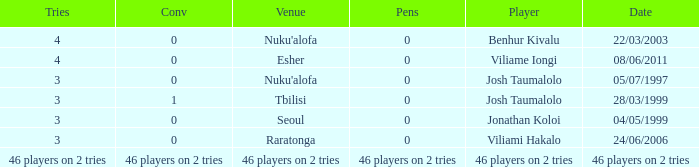What player played on 04/05/1999 with a conv of 0? Jonathan Koloi. 